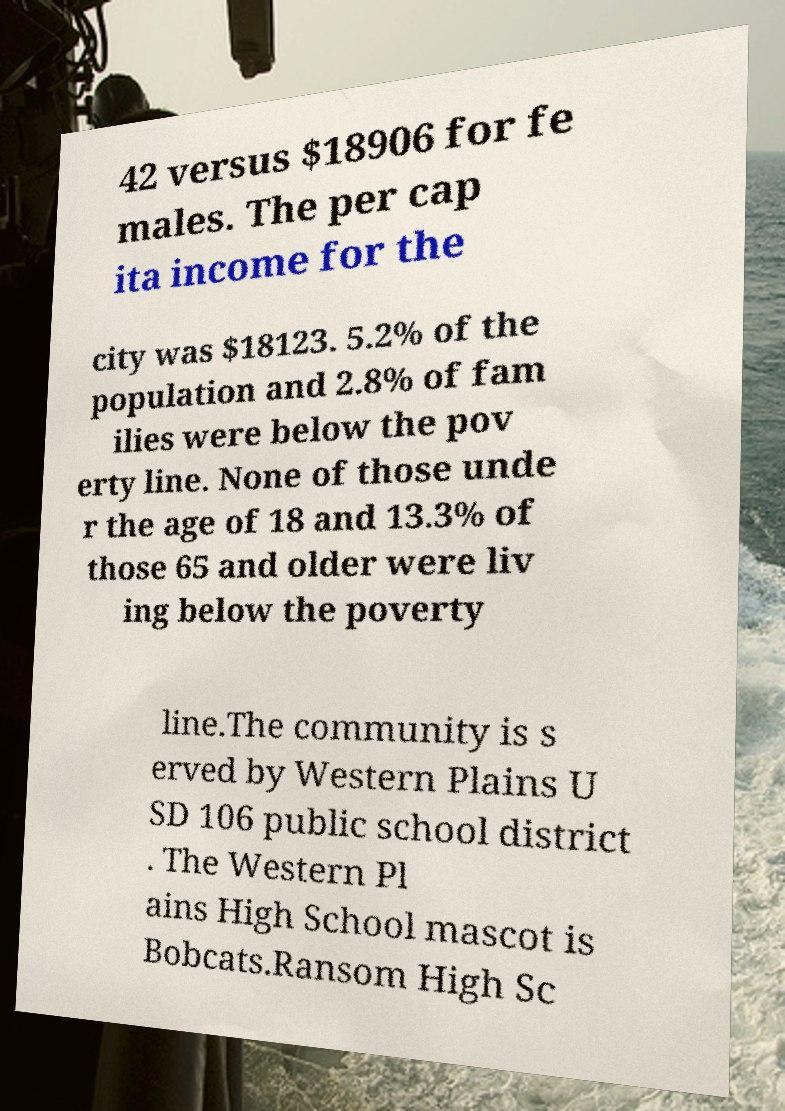Please identify and transcribe the text found in this image. 42 versus $18906 for fe males. The per cap ita income for the city was $18123. 5.2% of the population and 2.8% of fam ilies were below the pov erty line. None of those unde r the age of 18 and 13.3% of those 65 and older were liv ing below the poverty line.The community is s erved by Western Plains U SD 106 public school district . The Western Pl ains High School mascot is Bobcats.Ransom High Sc 